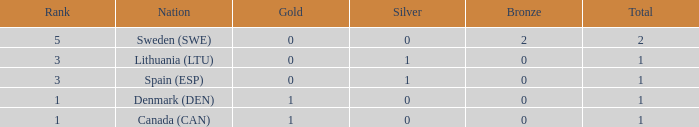What is the rank when there was less than 1 gold, 0 bronze, and more than 1 total? None. 